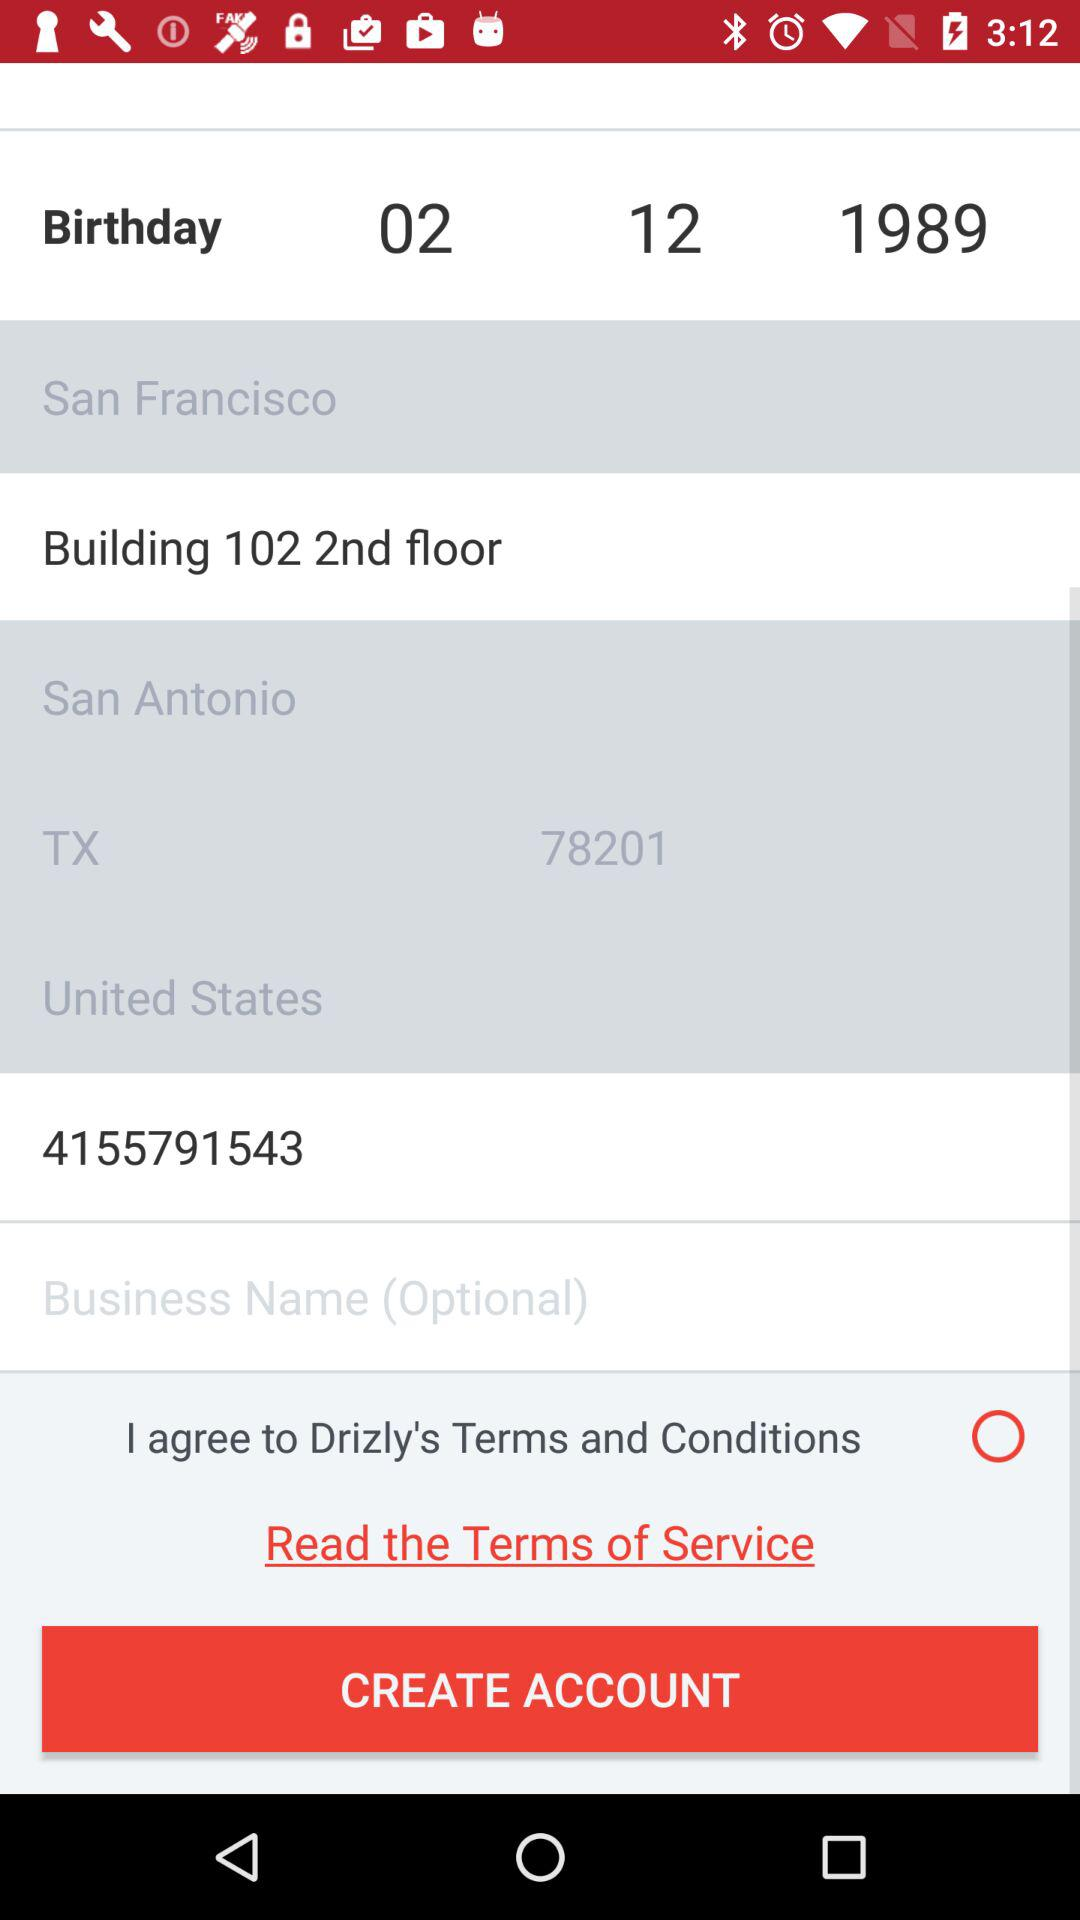What is the phone number? The phone number is 4155791543. 